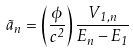<formula> <loc_0><loc_0><loc_500><loc_500>\tilde { a } _ { n } = \left ( \frac { \phi } { c ^ { 2 } } \right ) \frac { V _ { 1 , n } } { E _ { n } - E _ { 1 } }</formula> 